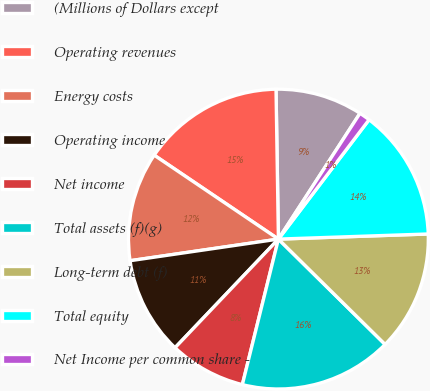Convert chart to OTSL. <chart><loc_0><loc_0><loc_500><loc_500><pie_chart><fcel>(Millions of Dollars except<fcel>Operating revenues<fcel>Energy costs<fcel>Operating income<fcel>Net income<fcel>Total assets (f)(g)<fcel>Long-term debt (f)<fcel>Total equity<fcel>Net Income per common share -<nl><fcel>9.41%<fcel>15.29%<fcel>11.76%<fcel>10.59%<fcel>8.24%<fcel>16.47%<fcel>12.94%<fcel>14.12%<fcel>1.18%<nl></chart> 